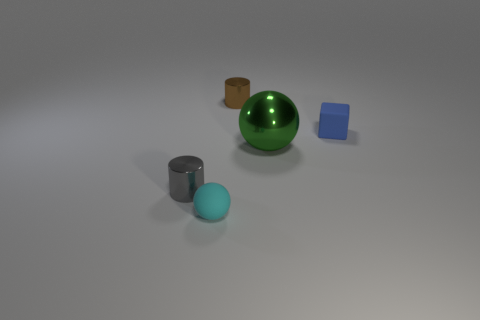Are there any brown things of the same shape as the tiny cyan matte object?
Ensure brevity in your answer.  No. What color is the other matte thing that is the same size as the blue thing?
Your response must be concise. Cyan. What material is the sphere on the right side of the cyan thing?
Keep it short and to the point. Metal. There is a small shiny thing that is in front of the tiny cube; does it have the same shape as the rubber object behind the large green metallic sphere?
Offer a very short reply. No. Is the number of small blue things that are in front of the block the same as the number of blue shiny spheres?
Offer a terse response. Yes. What number of cyan objects have the same material as the gray thing?
Provide a succinct answer. 0. What color is the block that is the same material as the tiny cyan sphere?
Provide a succinct answer. Blue. Is the size of the gray thing the same as the object behind the blue thing?
Offer a very short reply. Yes. What is the shape of the brown object?
Provide a succinct answer. Cylinder. How many metal objects are the same color as the rubber block?
Keep it short and to the point. 0. 